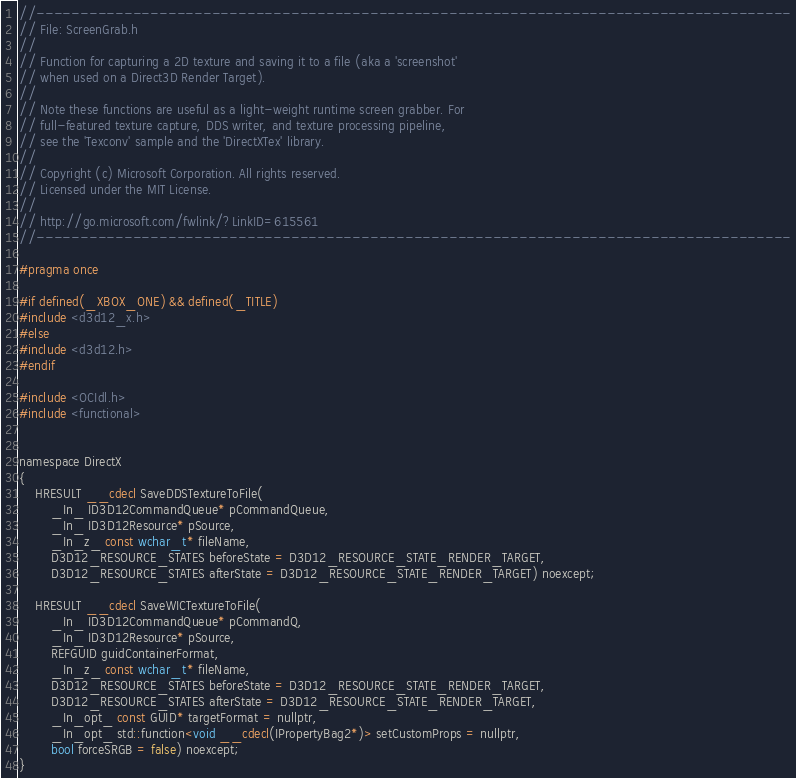<code> <loc_0><loc_0><loc_500><loc_500><_C_>//--------------------------------------------------------------------------------------
// File: ScreenGrab.h
//
// Function for capturing a 2D texture and saving it to a file (aka a 'screenshot'
// when used on a Direct3D Render Target).
//
// Note these functions are useful as a light-weight runtime screen grabber. For
// full-featured texture capture, DDS writer, and texture processing pipeline,
// see the 'Texconv' sample and the 'DirectXTex' library.
//
// Copyright (c) Microsoft Corporation. All rights reserved.
// Licensed under the MIT License.
//
// http://go.microsoft.com/fwlink/?LinkID=615561
//--------------------------------------------------------------------------------------

#pragma once

#if defined(_XBOX_ONE) && defined(_TITLE)
#include <d3d12_x.h>
#else
#include <d3d12.h>
#endif

#include <OCIdl.h>
#include <functional>


namespace DirectX
{
    HRESULT __cdecl SaveDDSTextureToFile(
        _In_ ID3D12CommandQueue* pCommandQueue,
        _In_ ID3D12Resource* pSource,
        _In_z_ const wchar_t* fileName,
        D3D12_RESOURCE_STATES beforeState = D3D12_RESOURCE_STATE_RENDER_TARGET,
        D3D12_RESOURCE_STATES afterState = D3D12_RESOURCE_STATE_RENDER_TARGET) noexcept;

    HRESULT __cdecl SaveWICTextureToFile(
        _In_ ID3D12CommandQueue* pCommandQ,
        _In_ ID3D12Resource* pSource,
        REFGUID guidContainerFormat,
        _In_z_ const wchar_t* fileName,
        D3D12_RESOURCE_STATES beforeState = D3D12_RESOURCE_STATE_RENDER_TARGET,
        D3D12_RESOURCE_STATES afterState = D3D12_RESOURCE_STATE_RENDER_TARGET,
        _In_opt_ const GUID* targetFormat = nullptr,
        _In_opt_ std::function<void __cdecl(IPropertyBag2*)> setCustomProps = nullptr,
        bool forceSRGB = false) noexcept;
}
</code> 